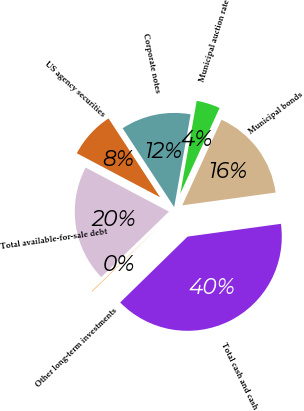<chart> <loc_0><loc_0><loc_500><loc_500><pie_chart><fcel>Total cash and cash<fcel>Municipal bonds<fcel>Municipal auction rate<fcel>Corporate notes<fcel>US agency securities<fcel>Total available-for-sale debt<fcel>Other long-term investments<nl><fcel>39.85%<fcel>15.99%<fcel>4.06%<fcel>12.01%<fcel>8.04%<fcel>19.97%<fcel>0.08%<nl></chart> 